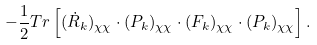Convert formula to latex. <formula><loc_0><loc_0><loc_500><loc_500>- \frac { 1 } { 2 } T r \left [ ( \dot { R } _ { k } ) _ { \chi \chi } \cdot ( P _ { k } ) _ { \chi \chi } \cdot ( F _ { k } ) _ { \chi \chi } \cdot ( P _ { k } ) _ { \chi \chi } \right ] .</formula> 